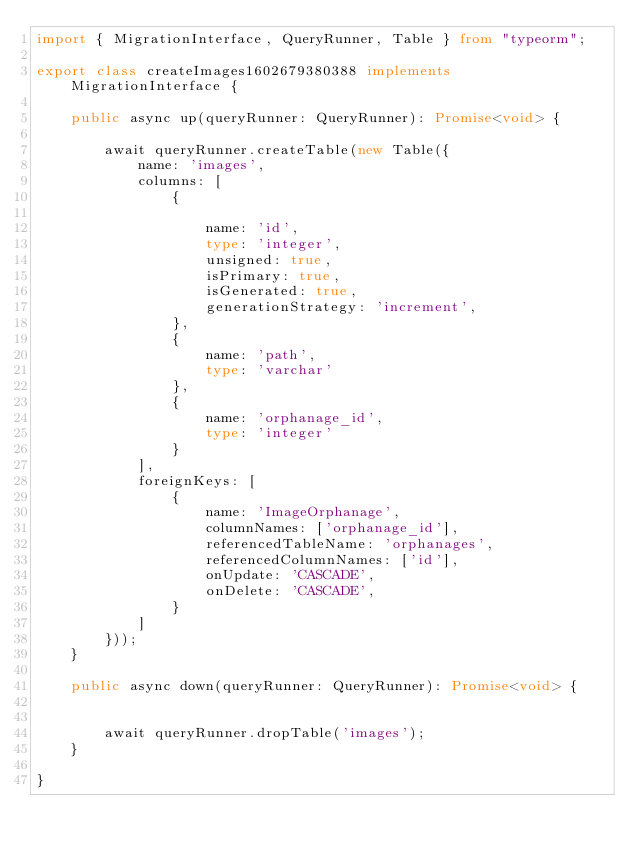<code> <loc_0><loc_0><loc_500><loc_500><_TypeScript_>import { MigrationInterface, QueryRunner, Table } from "typeorm";

export class createImages1602679380388 implements MigrationInterface {

    public async up(queryRunner: QueryRunner): Promise<void> {

        await queryRunner.createTable(new Table({
            name: 'images',
            columns: [
                {

                    name: 'id',
                    type: 'integer',
                    unsigned: true,
                    isPrimary: true,
                    isGenerated: true,
                    generationStrategy: 'increment',
                },
                {
                    name: 'path',
                    type: 'varchar'
                },
                {
                    name: 'orphanage_id',
                    type: 'integer'
                }
            ],
            foreignKeys: [
                {
                    name: 'ImageOrphanage',
                    columnNames: ['orphanage_id'],
                    referencedTableName: 'orphanages',
                    referencedColumnNames: ['id'],
                    onUpdate: 'CASCADE',
                    onDelete: 'CASCADE',
                }
            ]
        }));
    }

    public async down(queryRunner: QueryRunner): Promise<void> {


        await queryRunner.dropTable('images');
    }

}
</code> 